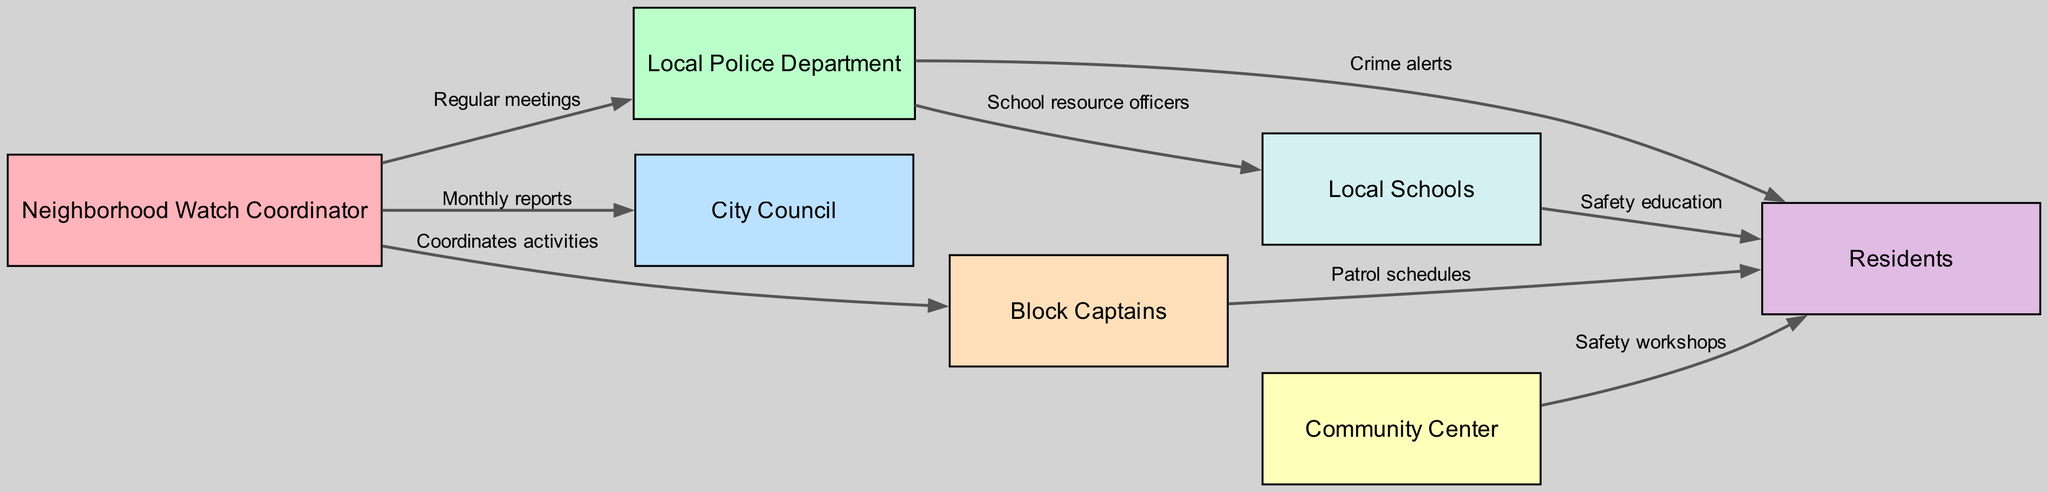What is the total number of nodes in the diagram? To find the total number of nodes, we can simply count the individual entries under the "nodes" section in the data provided. There are 7 nodes listed.
Answer: 7 What type of communication occurs between the Neighborhood Watch Coordinator and the Local Police Department? The communication channel is described as "Regular meetings" in the edges section connecting these two nodes.
Answer: Regular meetings How many edges are connected to the Residents node? To determine the number of edges connected to the Residents node (Node ID 6), we look through the "edges" section and count how many times Node ID 6 appears as the "to" node. There are 4 edges leading to Residents.
Answer: 4 Which stakeholder is responsible for coordinating activities among Block Captains? The edge connecting the Neighborhood Watch Coordinator to Block Captains indicates that the Neighborhood Watch Coordinator coordinates activities among them.
Answer: Neighborhood Watch Coordinator What is the relationship between Local Schools and Residents as depicted in the diagram? The relationship is identified as "Safety education," which is an edge that connects Local Schools to Residents.
Answer: Safety education How many different types of communication are illustrated in the diagram? To answer this, we can analyze the labels of each edge and see how many unique labels appear. The labels are: Regular meetings, Monthly reports, Coordinates activities, Crime alerts, Safety workshops, Patrol schedules, Safety education, and School resource officers, totaling 8 distinct types of communication.
Answer: 8 What role does the Community Center play in relation to the Residents? The relationship involves providing "Safety workshops" directed from the Community Center to the Residents, indicating the Community Center's role in educating and improving safety within the community.
Answer: Safety workshops Which two nodes have a direct communication labeled as "Crime alerts"? The edge labeled "Crime alerts" connects the Local Police Department and Residents directly, highlighting the communication of crime-related information to community members.
Answer: Local Police Department and Residents 